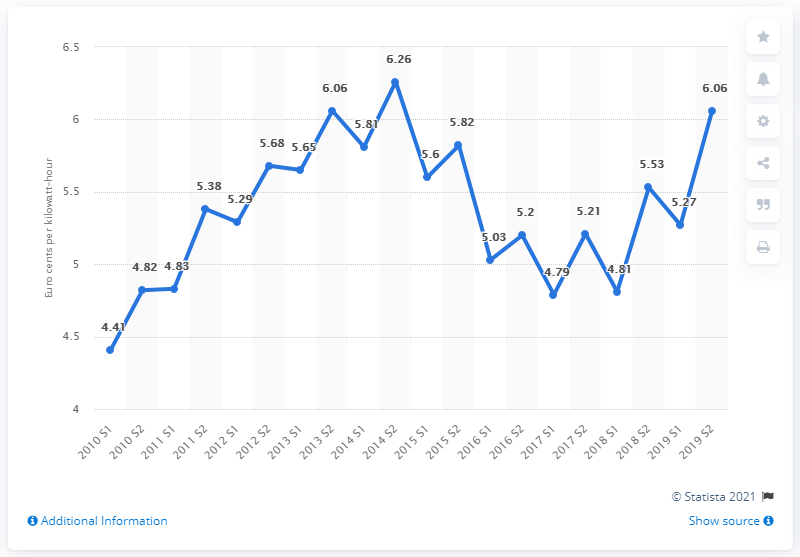Highlight a few significant elements in this photo. The difference between the prices of gas in the months in which the price was maximum and minimum is 1.85. In 2014, the line graph of saw its peak. 